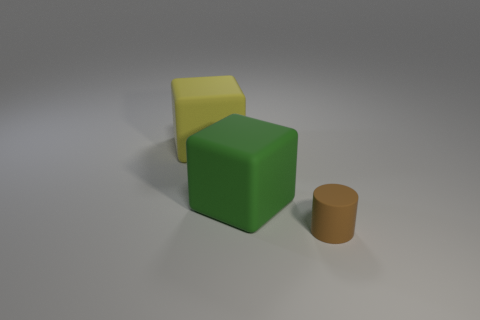Add 2 rubber things. How many objects exist? 5 Subtract all cubes. How many objects are left? 1 Subtract 0 cyan blocks. How many objects are left? 3 Subtract all large green objects. Subtract all tiny cylinders. How many objects are left? 1 Add 2 large things. How many large things are left? 4 Add 1 green blocks. How many green blocks exist? 2 